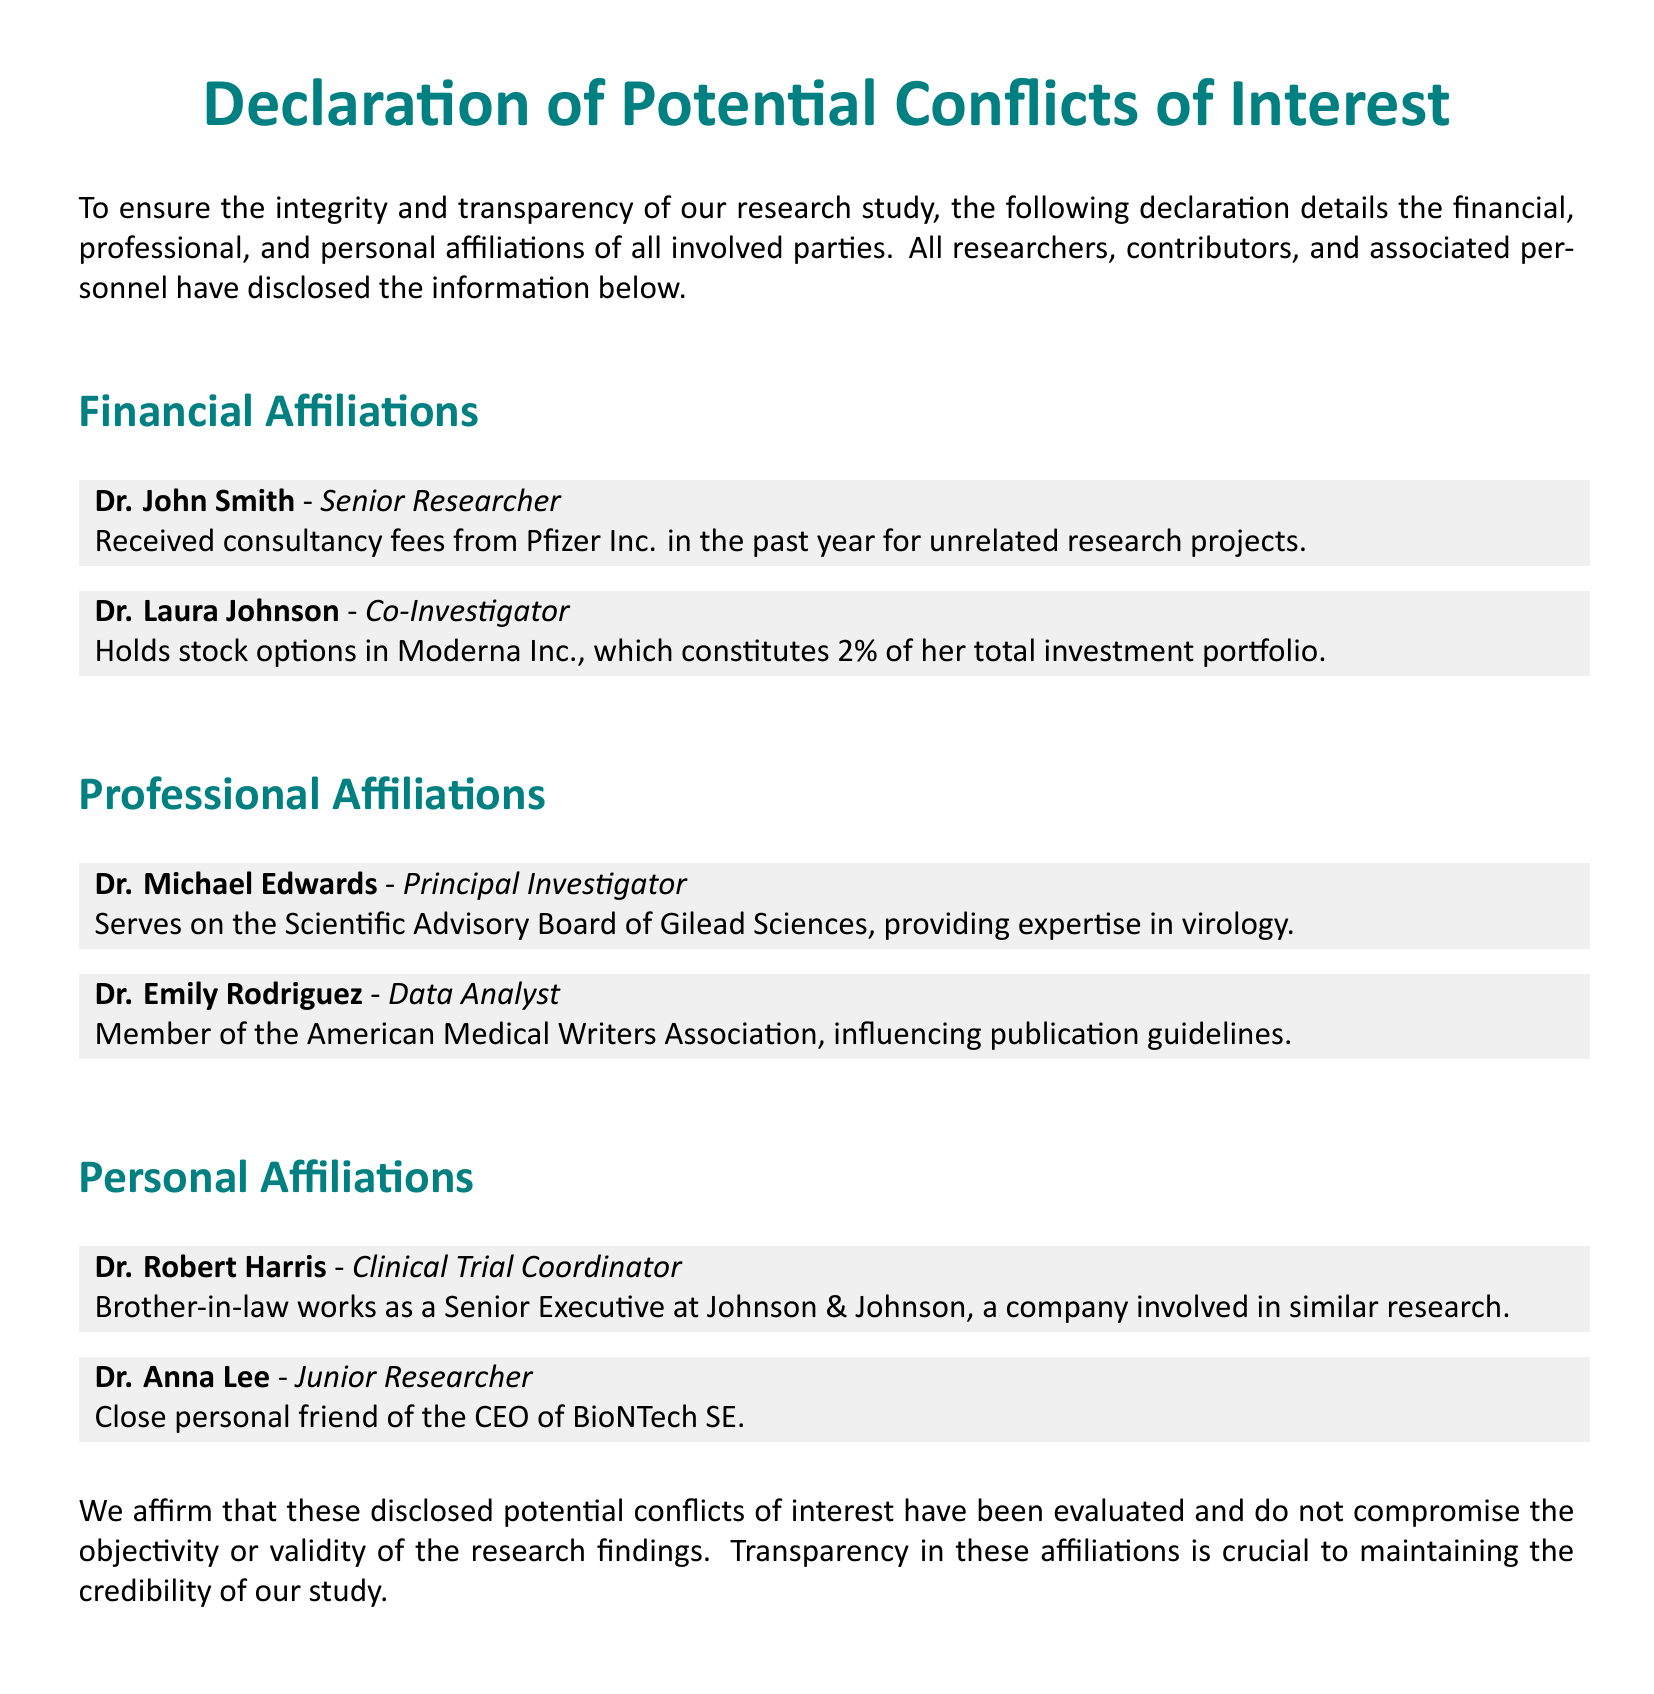What is the title of the document? The title appears at the top of the document, indicating what the document is about.
Answer: Declaration of Potential Conflicts of Interest Who is the Senior Researcher listed in the document? The document details the affiliations of all involved parties, specifying their roles.
Answer: Dr. John Smith What percentage of Dr. Laura Johnson's investment portfolio is attributed to Moderna Inc.? This information is found in her financial affiliation section, indicating the extent of her investment.
Answer: 2% Which company does Dr. Michael Edwards provide expertise for? The document states his professional affiliation, highlighting his advisory role.
Answer: Gilead Sciences What relation does Dr. Robert Harris have to a Senior Executive at Johnson & Johnson? The document mentions personal affiliations that may influence professional objectivity.
Answer: Brother-in-law What organization is Dr. Emily Rodriguez a member of? The document refers to her professional affiliations, pointing to professional memberships.
Answer: American Medical Writers Association How does the declaration describe the evaluation of disclosed potential conflicts of interest? The document emphasizes the importance of this evaluation for research integrity.
Answer: Evaluated What is the significance of transparency in affiliations according to the document? This portion of the declaration underlines the importance of transparency in relation to research credibility.
Answer: Maintaining credibility 